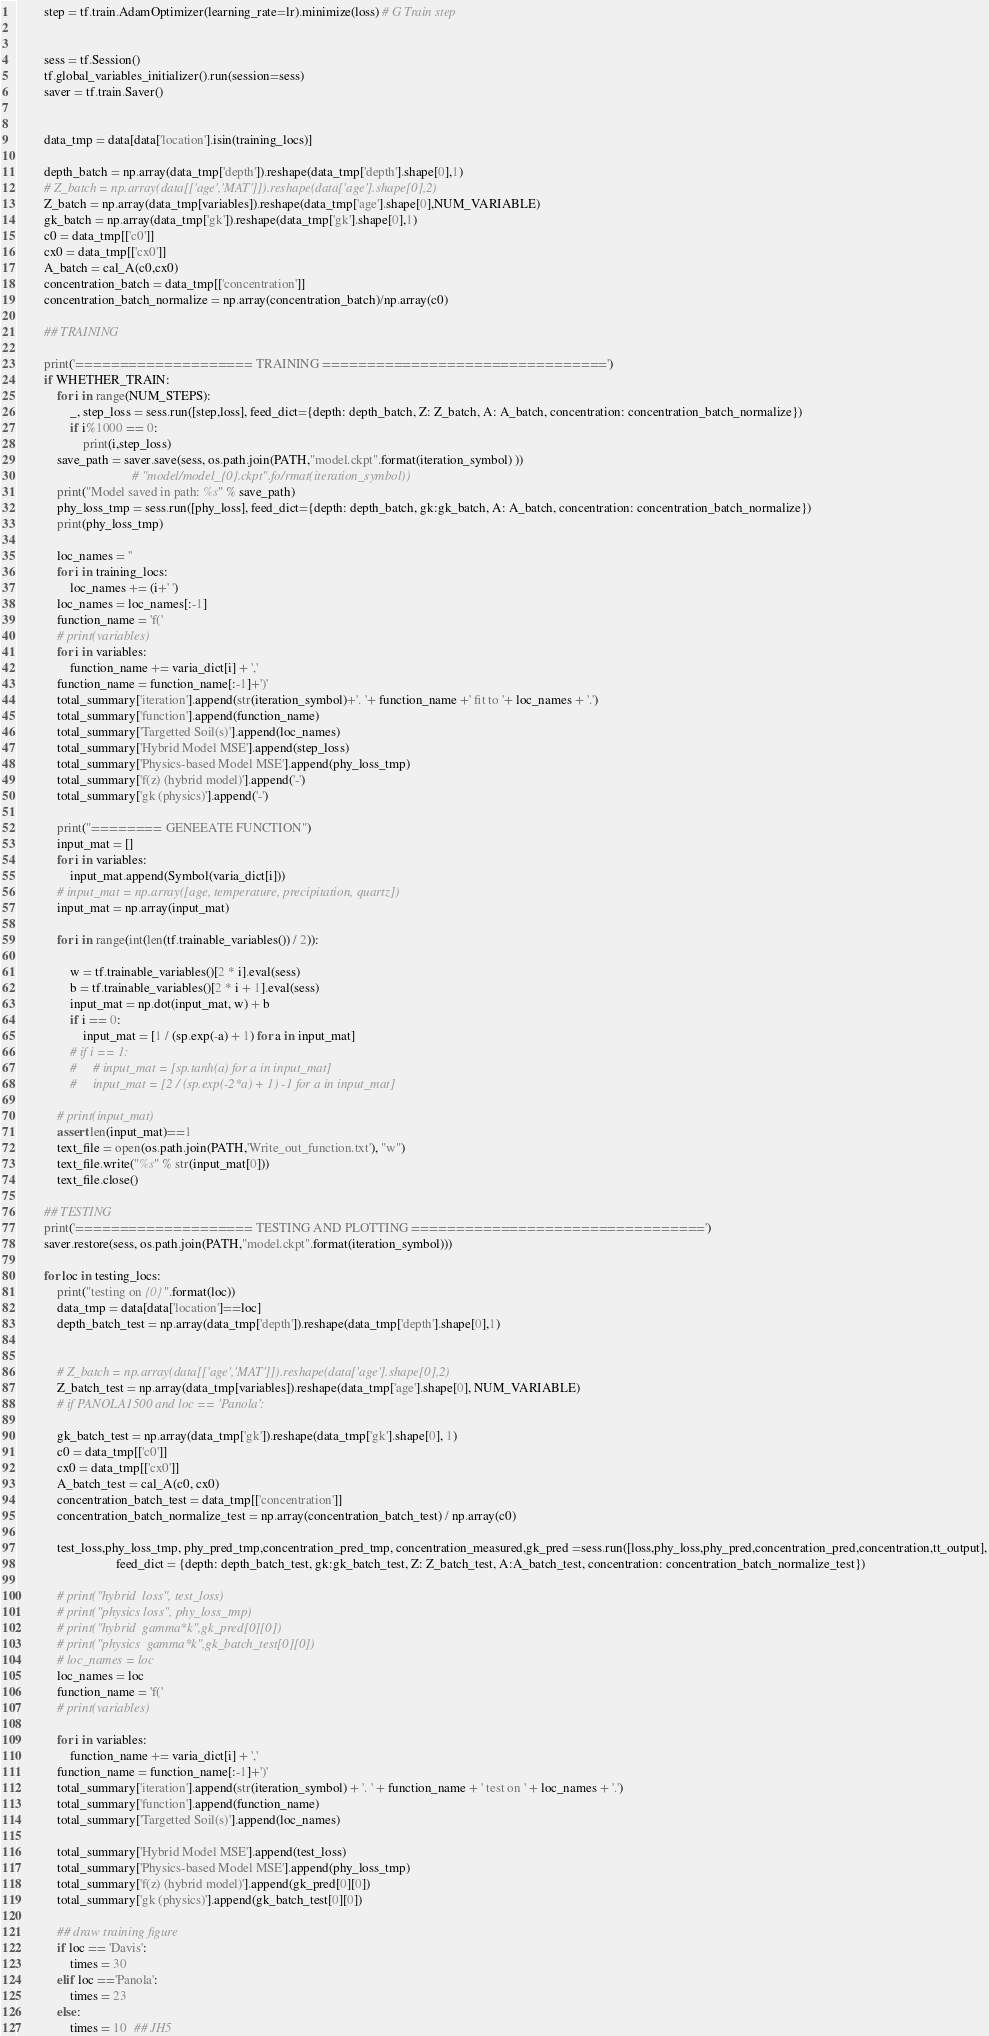<code> <loc_0><loc_0><loc_500><loc_500><_Python_>        step = tf.train.AdamOptimizer(learning_rate=lr).minimize(loss) # G Train step


        sess = tf.Session()
        tf.global_variables_initializer().run(session=sess)
        saver = tf.train.Saver()


        data_tmp = data[data['location'].isin(training_locs)]

        depth_batch = np.array(data_tmp['depth']).reshape(data_tmp['depth'].shape[0],1)
        # Z_batch = np.array(data[['age','MAT']]).reshape(data['age'].shape[0],2)
        Z_batch = np.array(data_tmp[variables]).reshape(data_tmp['age'].shape[0],NUM_VARIABLE)
        gk_batch = np.array(data_tmp['gk']).reshape(data_tmp['gk'].shape[0],1)
        c0 = data_tmp[['c0']]
        cx0 = data_tmp[['cx0']]
        A_batch = cal_A(c0,cx0)
        concentration_batch = data_tmp[['concentration']]
        concentration_batch_normalize = np.array(concentration_batch)/np.array(c0)

        ## TRAINING

        print('==================== TRAINING ================================')
        if WHETHER_TRAIN:
            for i in range(NUM_STEPS):
                _, step_loss = sess.run([step,loss], feed_dict={depth: depth_batch, Z: Z_batch, A: A_batch, concentration: concentration_batch_normalize})
                if i%1000 == 0:
                    print(i,step_loss)
            save_path = saver.save(sess, os.path.join(PATH,"model.ckpt".format(iteration_symbol) ))
                                   # "model/model_{0}.ckpt".fo/rmat(iteration_symbol))
            print("Model saved in path: %s" % save_path)
            phy_loss_tmp = sess.run([phy_loss], feed_dict={depth: depth_batch, gk:gk_batch, A: A_batch, concentration: concentration_batch_normalize})
            print(phy_loss_tmp)

            loc_names = ''
            for i in training_locs:
                loc_names += (i+' ')
            loc_names = loc_names[:-1]
            function_name = 'f('
            # print(variables)
            for i in variables:
                function_name += varia_dict[i] + ','
            function_name = function_name[:-1]+')'
            total_summary['iteration'].append(str(iteration_symbol)+'. '+ function_name +' fit to '+ loc_names + '.')
            total_summary['function'].append(function_name)
            total_summary['Targetted Soil(s)'].append(loc_names)
            total_summary['Hybrid Model MSE'].append(step_loss)
            total_summary['Physics-based Model MSE'].append(phy_loss_tmp)
            total_summary['f(z) (hybrid model)'].append('-')
            total_summary['gk (physics)'].append('-')

            print("======== GENEEATE FUNCTION")
            input_mat = []
            for i in variables:
                input_mat.append(Symbol(varia_dict[i]))
            # input_mat = np.array([age, temperature, precipitation, quartz])
            input_mat = np.array(input_mat)

            for i in range(int(len(tf.trainable_variables()) / 2)):

                w = tf.trainable_variables()[2 * i].eval(sess)
                b = tf.trainable_variables()[2 * i + 1].eval(sess)
                input_mat = np.dot(input_mat, w) + b
                if i == 0:
                    input_mat = [1 / (sp.exp(-a) + 1) for a in input_mat]
                # if i == 1:
                #     # input_mat = [sp.tanh(a) for a in input_mat]
                #     input_mat = [2 / (sp.exp(-2*a) + 1) -1 for a in input_mat]

            # print(input_mat)
            assert len(input_mat)==1
            text_file = open(os.path.join(PATH,'Write_out_function.txt'), "w")
            text_file.write("%s" % str(input_mat[0]))
            text_file.close()

        ## TESTING
        print('==================== TESTING AND PLOTTING =================================')
        saver.restore(sess, os.path.join(PATH,"model.ckpt".format(iteration_symbol)))

        for loc in testing_locs:
            print("testing on {0}".format(loc))
            data_tmp = data[data['location']==loc]
            depth_batch_test = np.array(data_tmp['depth']).reshape(data_tmp['depth'].shape[0],1)


            # Z_batch = np.array(data[['age','MAT']]).reshape(data['age'].shape[0],2)
            Z_batch_test = np.array(data_tmp[variables]).reshape(data_tmp['age'].shape[0], NUM_VARIABLE)
            # if PANOLA1500 and loc == 'Panola':

            gk_batch_test = np.array(data_tmp['gk']).reshape(data_tmp['gk'].shape[0], 1)
            c0 = data_tmp[['c0']]
            cx0 = data_tmp[['cx0']]
            A_batch_test = cal_A(c0, cx0)
            concentration_batch_test = data_tmp[['concentration']]
            concentration_batch_normalize_test = np.array(concentration_batch_test) / np.array(c0)

            test_loss,phy_loss_tmp, phy_pred_tmp,concentration_pred_tmp, concentration_measured,gk_pred =sess.run([loss,phy_loss,phy_pred,concentration_pred,concentration,tt_output],
                              feed_dict = {depth: depth_batch_test, gk:gk_batch_test, Z: Z_batch_test, A:A_batch_test, concentration: concentration_batch_normalize_test})

            # print("hybrid  loss", test_loss)
            # print("physics loss", phy_loss_tmp)
            # print("hybrid  gamma*k",gk_pred[0][0])
            # print("physics  gamma*k",gk_batch_test[0][0])
            # loc_names = loc
            loc_names = loc
            function_name = 'f('
            # print(variables)

            for i in variables:
                function_name += varia_dict[i] + ','
            function_name = function_name[:-1]+')'
            total_summary['iteration'].append(str(iteration_symbol) + '. ' + function_name + ' test on ' + loc_names + '.')
            total_summary['function'].append(function_name)
            total_summary['Targetted Soil(s)'].append(loc_names)

            total_summary['Hybrid Model MSE'].append(test_loss)
            total_summary['Physics-based Model MSE'].append(phy_loss_tmp)
            total_summary['f(z) (hybrid model)'].append(gk_pred[0][0])
            total_summary['gk (physics)'].append(gk_batch_test[0][0])

            ## draw training figure
            if loc == 'Davis':
                times = 30
            elif loc =='Panola':
                times = 23
            else:
                times = 10  ## JH5
</code> 